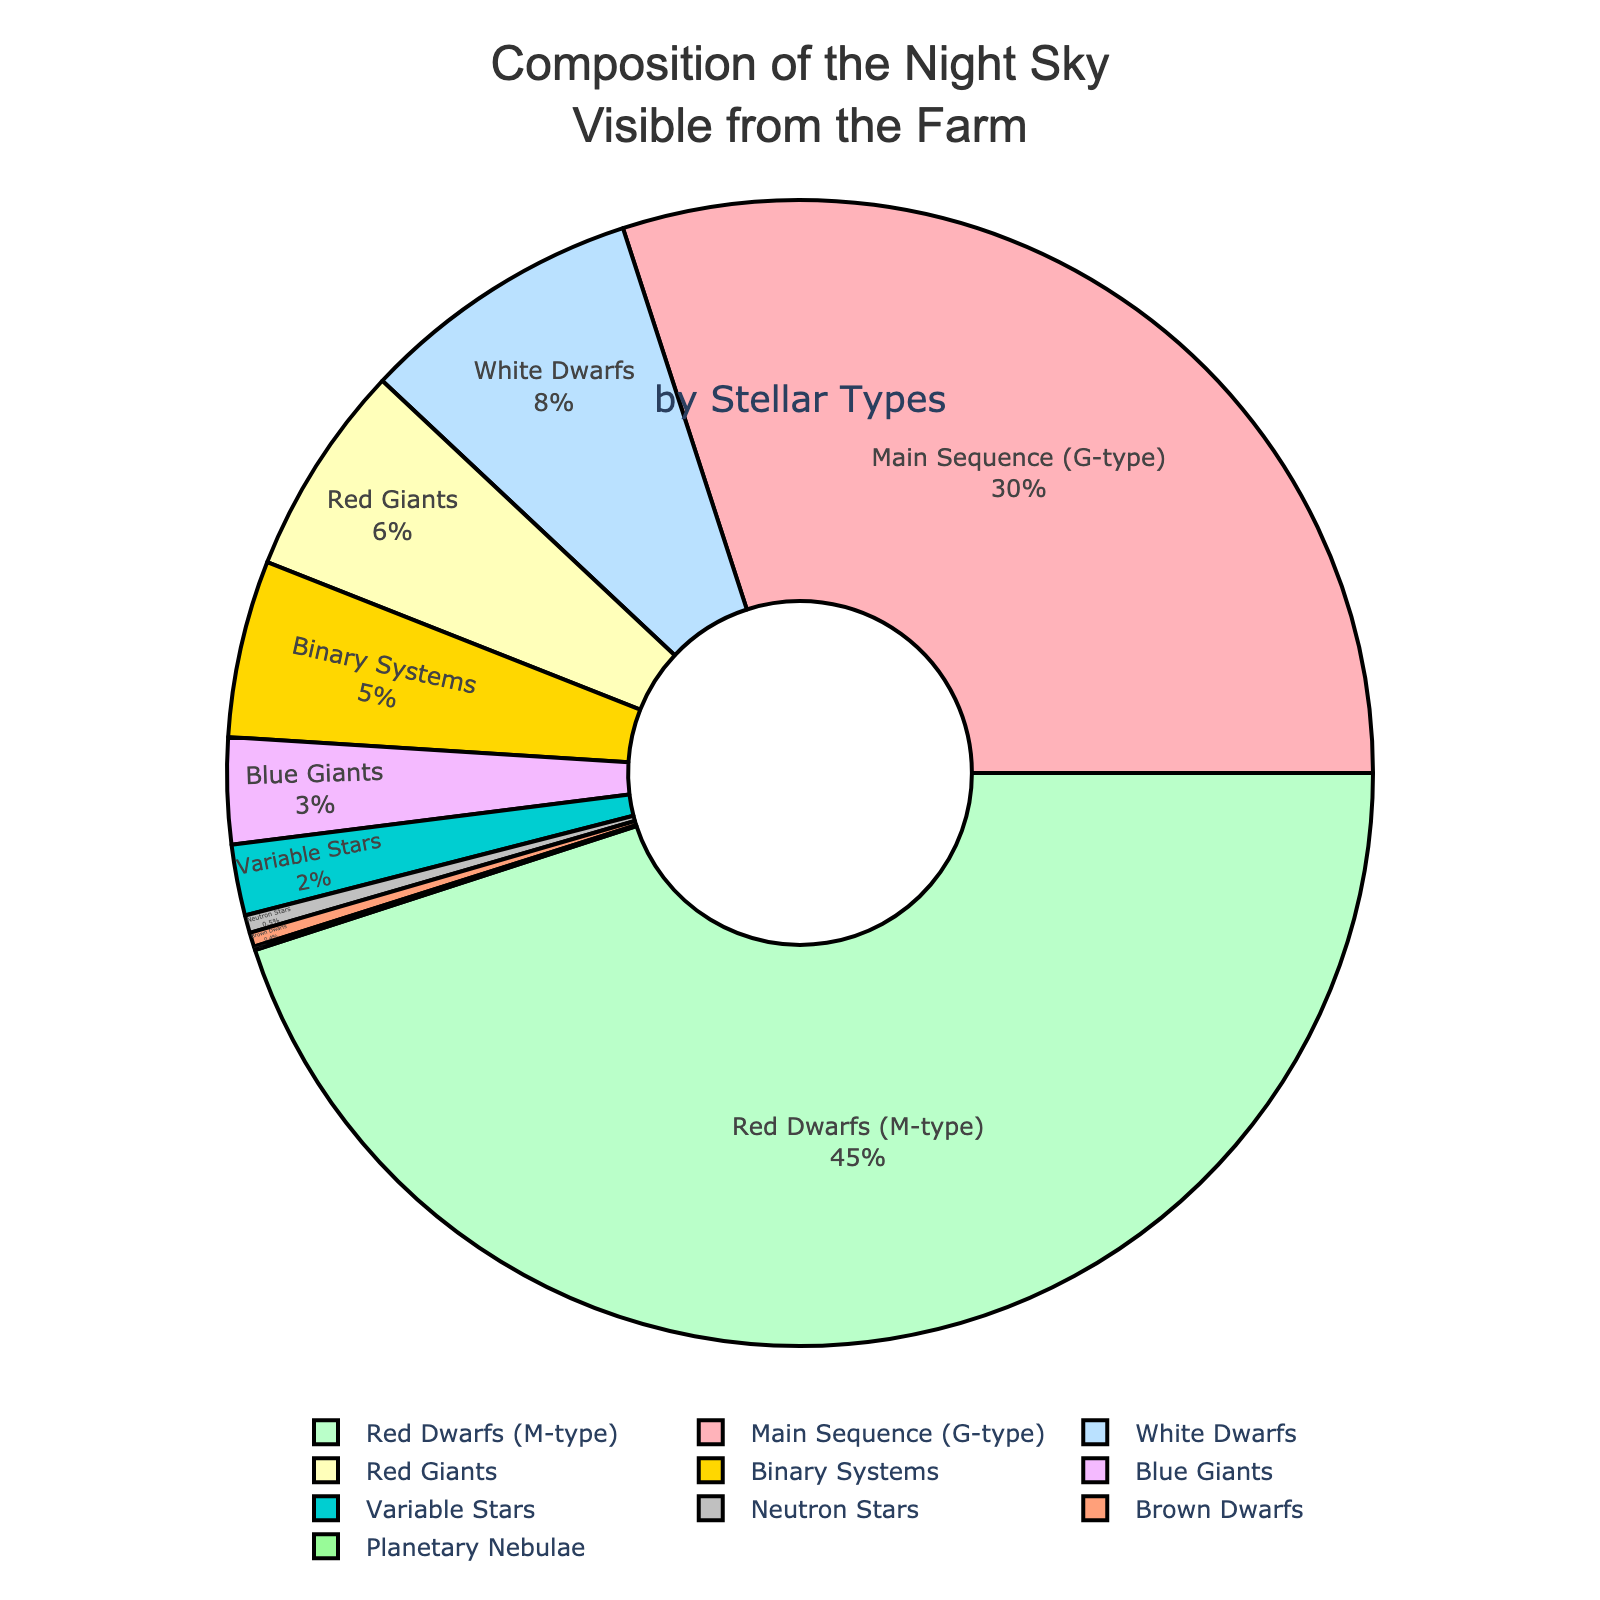What is the most common stellar type visible from the farm? The most common stellar type can be identified by the segment of the pie chart with the largest percentage. In this case, it's the Red Dwarfs (M-type) with 45%.
Answer: Red Dwarfs (M-type) How many more Red Dwarfs (M-type) are there than G-type main sequence stars? First, find the percentages of Red Dwarfs (45%) and G-type main sequence stars (30%). Then subtract the percentage of G-type stars from Red Dwarfs: 45% - 30% = 15%.
Answer: 15% What is the collective percentage of Binary Systems, Neutron Stars, Variable Stars, Brown Dwarfs, and Planetary Nebulae? Add the percentages of each of these stellar types: 5% (Binary Systems) + 0.5% (Neutron Stars) + 2% (Variable Stars) + 0.4% (Brown Dwarfs) + 0.1% (Planetary Nebulae) = 8%.
Answer: 8% Are there more Red Giants or White Dwarfs? Compare the percentages of Red Giants (6%) and White Dwarfs (8%). Since 8% is greater than 6%, there are more White Dwarfs.
Answer: White Dwarfs Which stellar type has the smallest representation in the night sky? Identify the segment with the smallest percentage in the pie chart. In this case, it's the Planetary Nebulae with 0.1%.
Answer: Planetary Nebulae What is the percentage difference between Blue Giants and Brown Dwarfs? Calculate the absolute difference in percentages: 3% (Blue Giants) - 0.4% (Brown Dwarfs) = 2.6%.
Answer: 2.6% Which color represents the Red Giants in the pie chart? By examining the colors used, it can be identified that Red Giants (6%) are represented by the color closest to purple or magenta in the pie chart.
Answer: Purple or magenta What percentage of the night sky do White Dwarfs and Blue Giants together make up? Add the percentages of White Dwarfs (8%) and Blue Giants (3%): 8% + 3% = 11%.
Answer: 11% If we combine the percentages of Red Dwarfs and G-type main sequence stars, what is their total contribution to the night sky? Sum the percentages of Red Dwarfs (45%) and G-type main sequence stars (30%): 45% + 30% = 75%.
Answer: 75% 